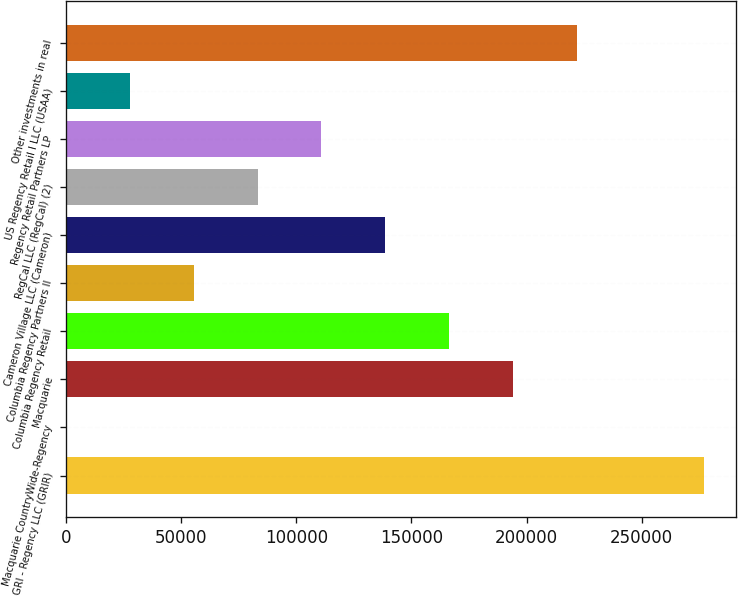<chart> <loc_0><loc_0><loc_500><loc_500><bar_chart><fcel>GRI - Regency LLC (GRIR)<fcel>Macquarie CountryWide-Regency<fcel>Macquarie<fcel>Columbia Regency Retail<fcel>Columbia Regency Partners II<fcel>Cameron Village LLC (Cameron)<fcel>RegCal LLC (RegCal) (2)<fcel>Regency Retail Partners LP<fcel>US Regency Retail I LLC (USAA)<fcel>Other investments in real<nl><fcel>277235<fcel>63<fcel>194083<fcel>166366<fcel>55497.4<fcel>138649<fcel>83214.6<fcel>110932<fcel>27780.2<fcel>221801<nl></chart> 